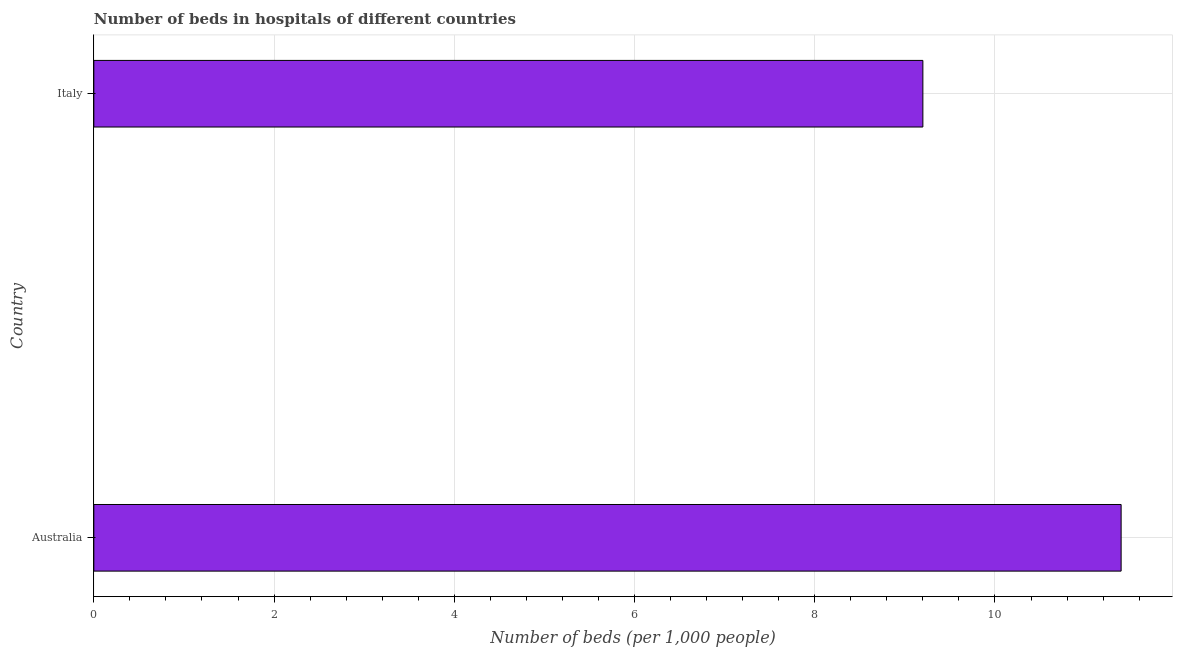Does the graph contain any zero values?
Your answer should be compact. No. What is the title of the graph?
Provide a short and direct response. Number of beds in hospitals of different countries. What is the label or title of the X-axis?
Give a very brief answer. Number of beds (per 1,0 people). What is the label or title of the Y-axis?
Your response must be concise. Country. What is the number of hospital beds in Italy?
Your response must be concise. 9.2. Across all countries, what is the maximum number of hospital beds?
Ensure brevity in your answer.  11.4. Across all countries, what is the minimum number of hospital beds?
Offer a terse response. 9.2. In which country was the number of hospital beds minimum?
Your response must be concise. Italy. What is the sum of the number of hospital beds?
Keep it short and to the point. 20.6. What is the average number of hospital beds per country?
Ensure brevity in your answer.  10.3. What is the median number of hospital beds?
Offer a terse response. 10.3. What is the ratio of the number of hospital beds in Australia to that in Italy?
Your answer should be compact. 1.24. How many bars are there?
Give a very brief answer. 2. Are all the bars in the graph horizontal?
Give a very brief answer. Yes. How many countries are there in the graph?
Give a very brief answer. 2. What is the difference between two consecutive major ticks on the X-axis?
Provide a succinct answer. 2. Are the values on the major ticks of X-axis written in scientific E-notation?
Offer a terse response. No. What is the Number of beds (per 1,000 people) of Australia?
Keep it short and to the point. 11.4. What is the Number of beds (per 1,000 people) in Italy?
Provide a short and direct response. 9.2. What is the ratio of the Number of beds (per 1,000 people) in Australia to that in Italy?
Offer a terse response. 1.24. 